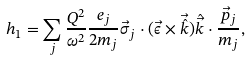<formula> <loc_0><loc_0><loc_500><loc_500>h _ { 1 } = \sum _ { j } \frac { Q ^ { 2 } } { \omega ^ { 2 } } \frac { e _ { j } } { 2 m _ { j } } \vec { \sigma } _ { j } \cdot ( \vec { \epsilon } \times \vec { \hat { k } } ) \hat { \vec { k } } \cdot \frac { \vec { p } _ { j } } { m _ { j } } ,</formula> 